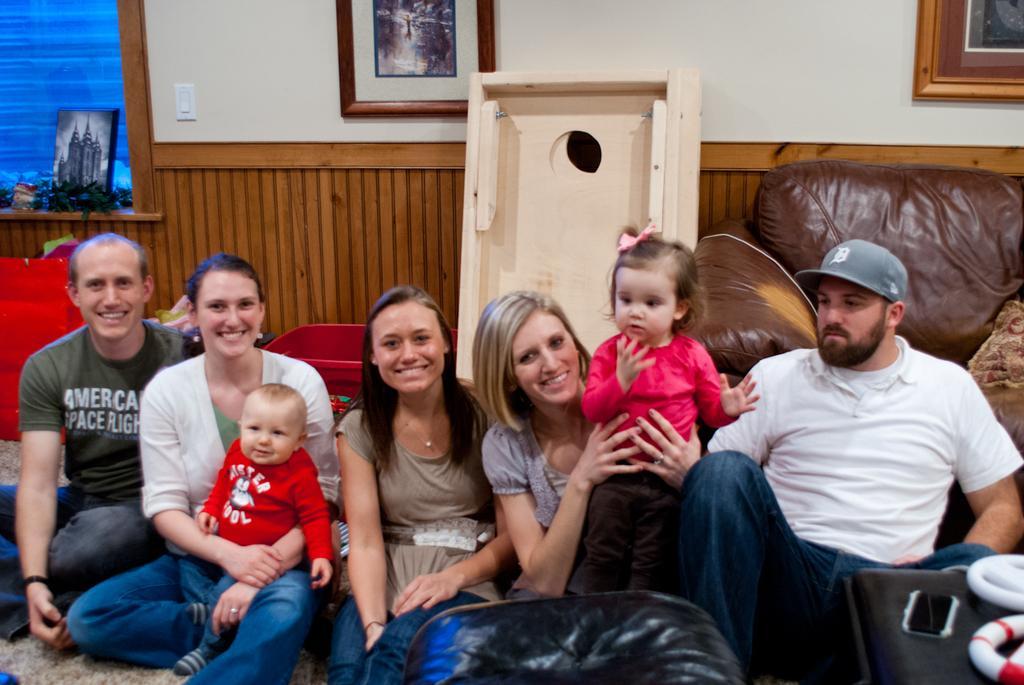In one or two sentences, can you explain what this image depicts? In this picture I can see there are few people standing here and there are two kids and in the backdrop I can see there is a wall with a photo frame. 